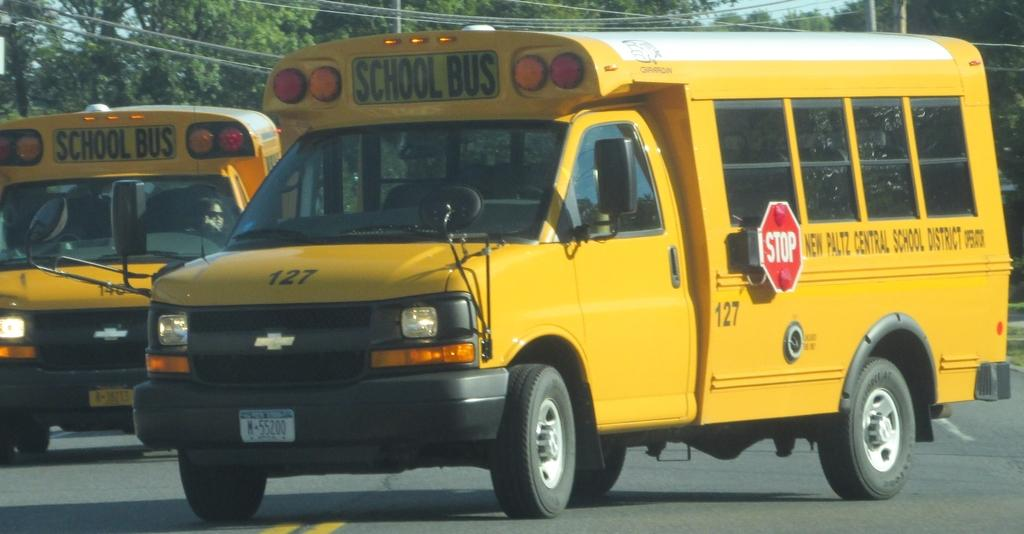Provide a one-sentence caption for the provided image. A yellow school bus #127 from New Platz Central School District is shown on the road. 